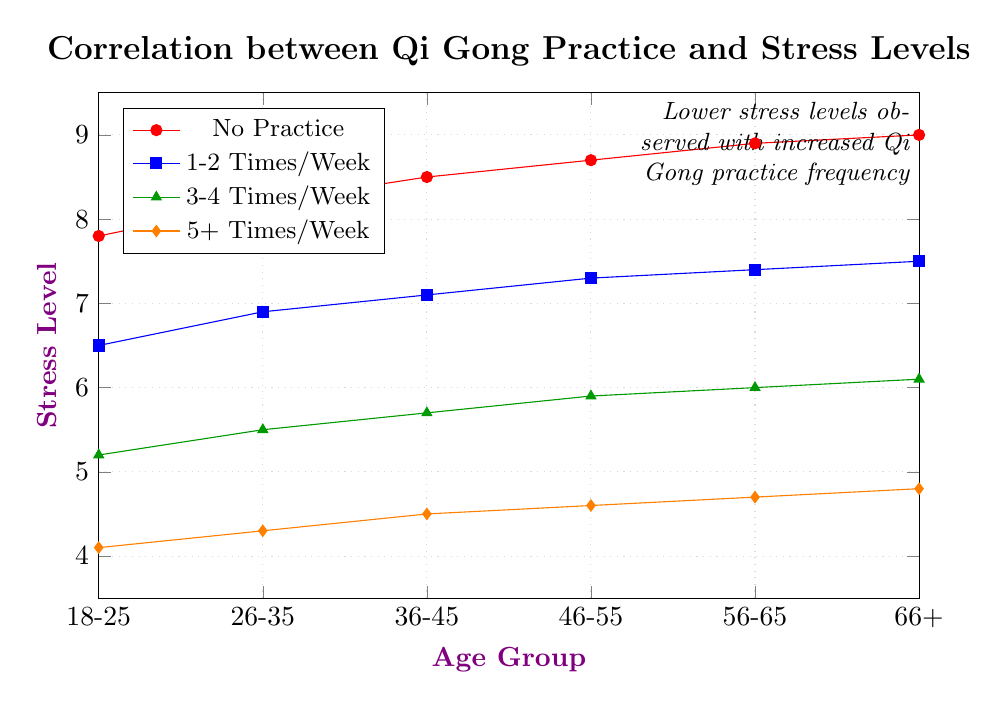What is the stress level for the 36-45 age group with no Qi Gong practice? Locate the "No Practice" line in the legend, then find the corresponding data point above the 36-45 age group on the x-axis. The data value at that point is the stress level.
Answer: 8.5 Which age group has the lowest stress level when practicing Qi Gong 5+ times per week? Identify the line corresponding to "5+ Times/Week" from the legend and then look for the lowest data point along that line. Check the corresponding x-axis value to determine the age group.
Answer: 18-25 How does the stress level for the 56-65 age group compare between no practice and 1-2 times per week? Identify the data points on the graph corresponding to the 56-65 age group for both "No Practice" and "1-2 Times/Week" lines. Compare these two values.
Answer: No Practice: 8.9, 1-2 Times/Week: 7.4 What's the difference in stress levels between the 18-25 and 66+ age groups for those who practice 3-4 times per week? Locate the "3-4 Times/Week" line from the legend and note the stress levels for both the 18-25 and the 66+ age groups. Subtract these values.
Answer: 6.1 - 5.2 = 0.9 Which practice frequency shows the steepest decline in stress levels across all age groups? Compare the slopes of the lines for "No Practice," "1-2 Times/Week," "3-4 Times/Week," and "5+ Times/Week" by visually assessing which line drops the most from left to right.
Answer: 5+ Times/Week What is the average stress level for the 46-55 age group considering all Qi Gong practice frequencies? Sum the stress levels for the 46-55 age group across all practice frequencies and divide by the number of frequencies (4).
Answer: (8.7 + 7.3 + 5.9 + 4.6) / 4 = 6.625 At which practice frequency do the stress levels differ the least between the youngest (18-25) and oldest (66+) age groups? For each practice frequency, compute the absolute difference in stress levels between the 18-25 and 66+ age groups and determine the smallest difference.
Answer: 5+ Times/Week Which age group shows the smallest reduction in stress levels when moving from "No Practice" to practicing 1-2 times per week? Calculate the difference in stress levels going from "No Practice" to "1-2 Times/Week" for each age group and find the smallest difference.
Answer: 66+ (9.0 - 7.5 = 1.5) How do the stress levels of the 26-35 age group compare between 3-4 times/week and 5+ times/week practices? Identify the stress levels on the graph for the 26-35 age group for both "3-4 Times/Week" and "5+ Times/Week" and compare the values.
Answer: 3-4 Times/Week: 5.5, 5+ Times/Week: 4.3 